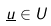<formula> <loc_0><loc_0><loc_500><loc_500>\underline { u } \in U</formula> 